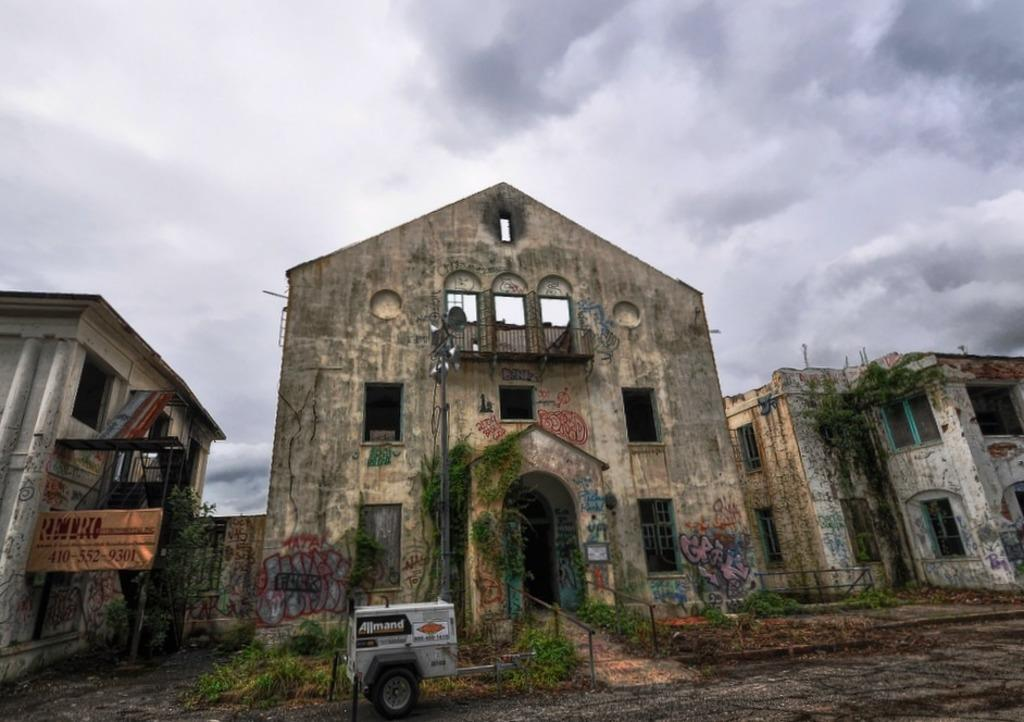What is located on the ground in the image? There is a vehicle on the ground in the image. What can be seen near the vehicle? There is a name board in the image. What type of vegetation is present in the image? There are plants in the image. What structure is visible in the image? There is a pole in the image. What type of buildings can be seen in the image? There are buildings with windows in the image. What is visible in the background of the image? The sky with clouds is visible in the background of the image. What reward is given to the person who answers the question correctly in the image? There is no indication of a question or reward in the image; it simply shows a vehicle, name board, plants, pole, buildings, and the sky with clouds. 